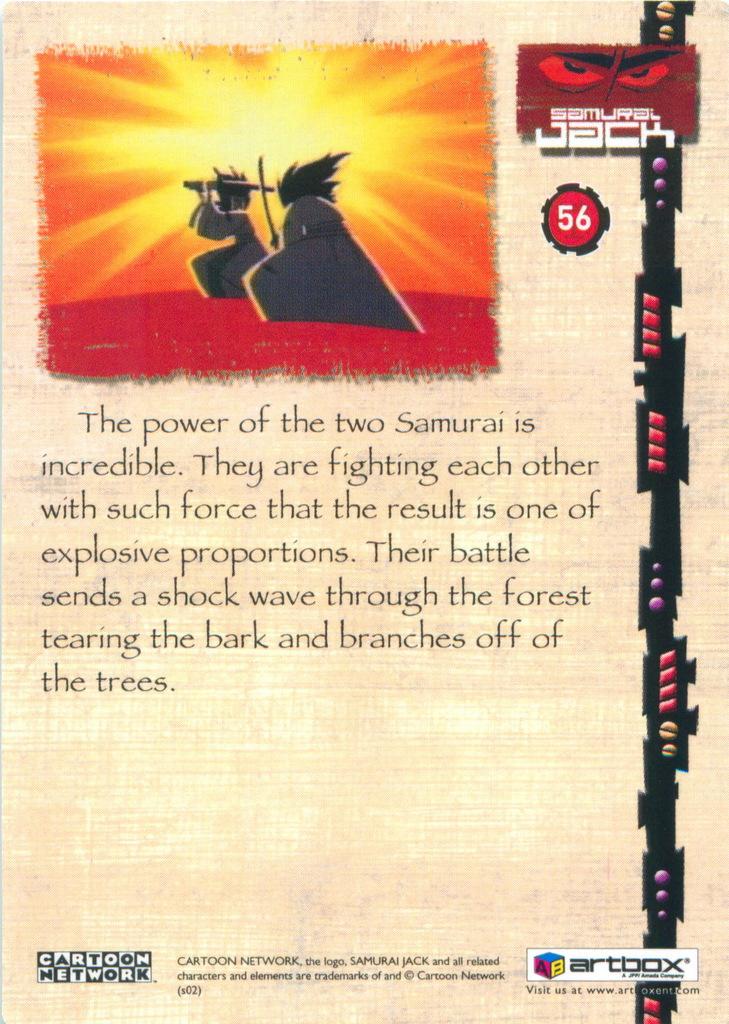The power of what is incredible, according to the text?
Offer a terse response. Two samurai. What network is in the bottom left corner?
Keep it short and to the point. Cartoon network. 